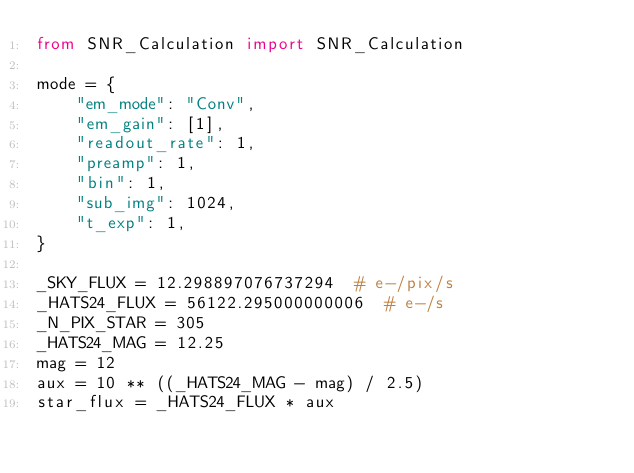Convert code to text. <code><loc_0><loc_0><loc_500><loc_500><_Python_>from SNR_Calculation import SNR_Calculation

mode = {
    "em_mode": "Conv",
    "em_gain": [1],
    "readout_rate": 1,
    "preamp": 1,
    "bin": 1,
    "sub_img": 1024,
    "t_exp": 1,
}

_SKY_FLUX = 12.298897076737294  # e-/pix/s
_HATS24_FLUX = 56122.295000000006  # e-/s
_N_PIX_STAR = 305
_HATS24_MAG = 12.25
mag = 12
aux = 10 ** ((_HATS24_MAG - mag) / 2.5)
star_flux = _HATS24_FLUX * aux

</code> 